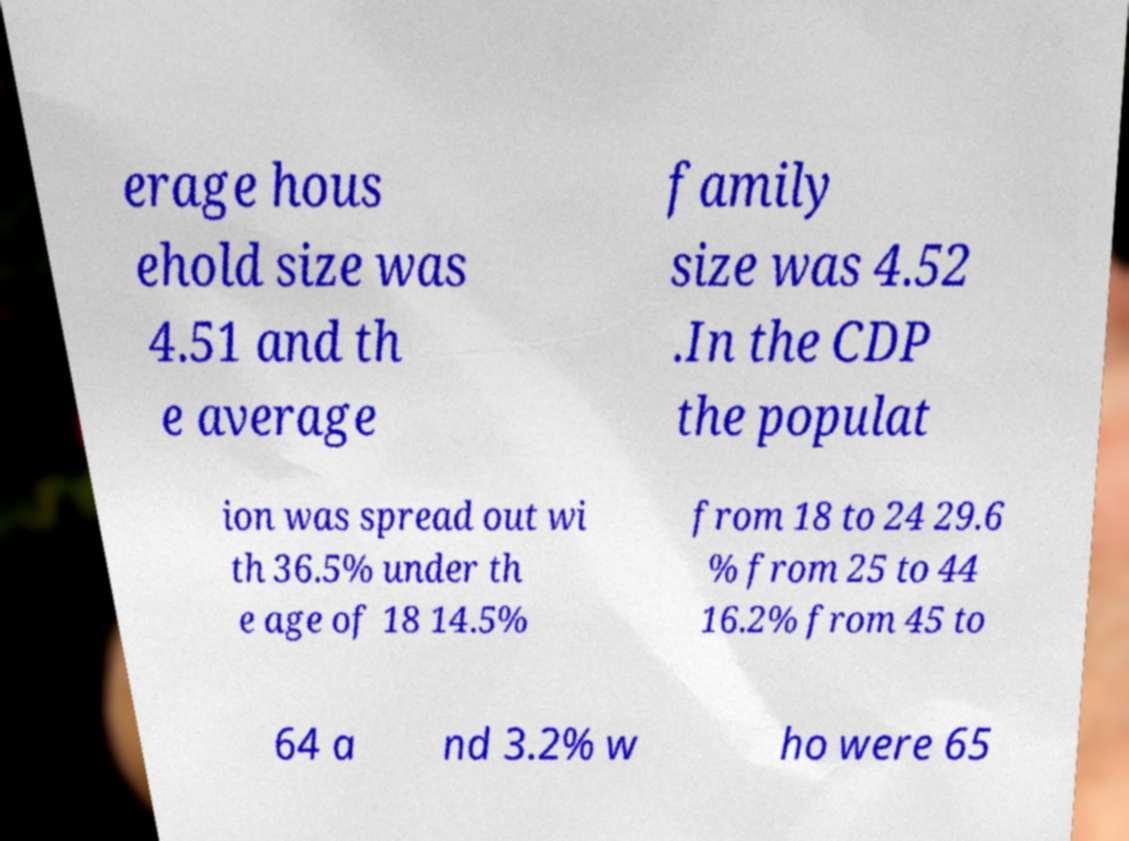Please identify and transcribe the text found in this image. erage hous ehold size was 4.51 and th e average family size was 4.52 .In the CDP the populat ion was spread out wi th 36.5% under th e age of 18 14.5% from 18 to 24 29.6 % from 25 to 44 16.2% from 45 to 64 a nd 3.2% w ho were 65 